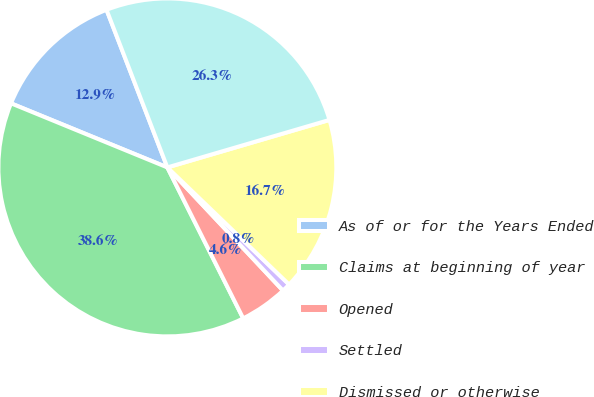Convert chart. <chart><loc_0><loc_0><loc_500><loc_500><pie_chart><fcel>As of or for the Years Ended<fcel>Claims at beginning of year<fcel>Opened<fcel>Settled<fcel>Dismissed or otherwise<fcel>Claims at end of year<nl><fcel>12.95%<fcel>38.61%<fcel>4.59%<fcel>0.81%<fcel>16.73%<fcel>26.33%<nl></chart> 